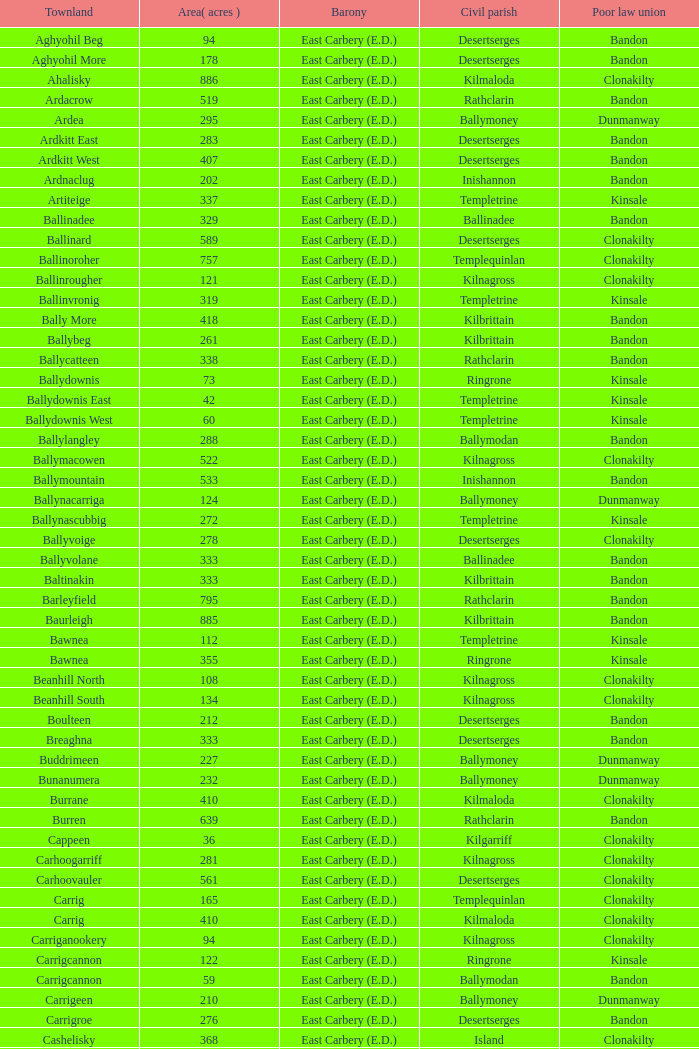Can you identify the poor law union associated with the townland of ardacrow? Bandon. 